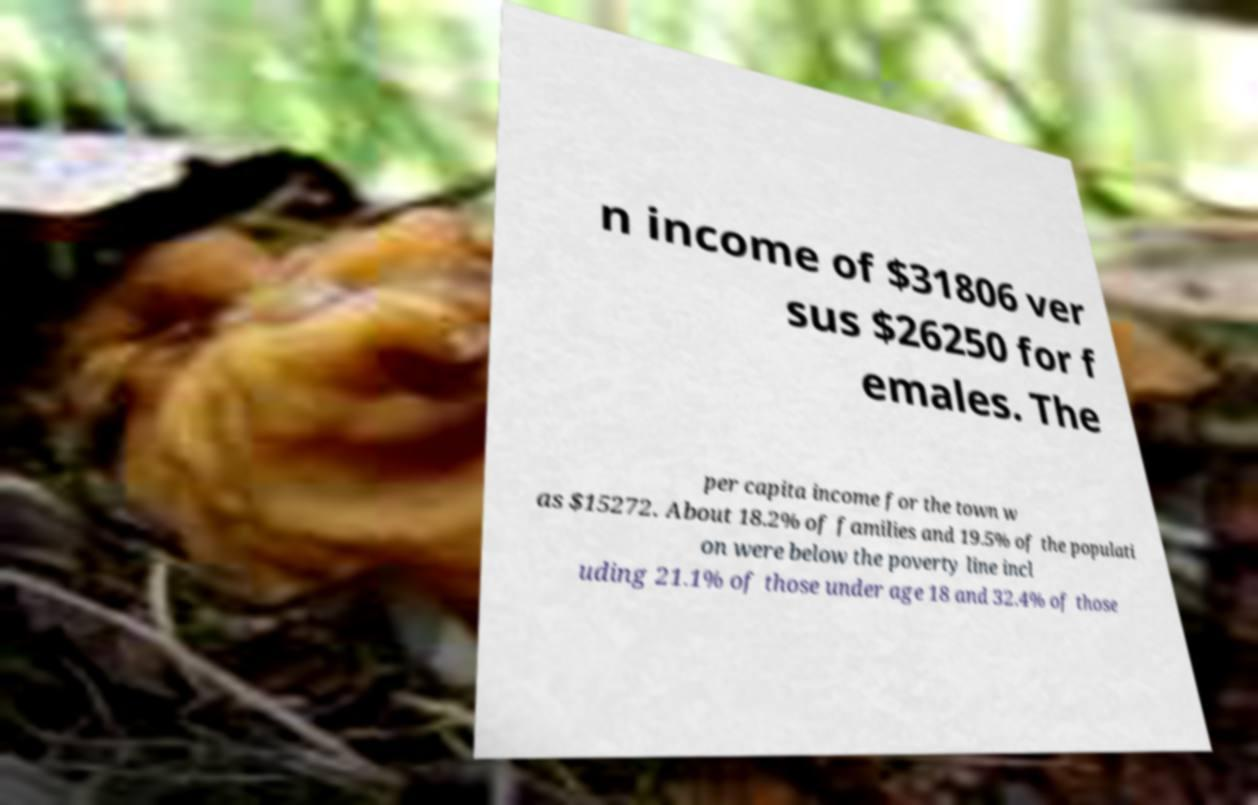Can you read and provide the text displayed in the image?This photo seems to have some interesting text. Can you extract and type it out for me? n income of $31806 ver sus $26250 for f emales. The per capita income for the town w as $15272. About 18.2% of families and 19.5% of the populati on were below the poverty line incl uding 21.1% of those under age 18 and 32.4% of those 